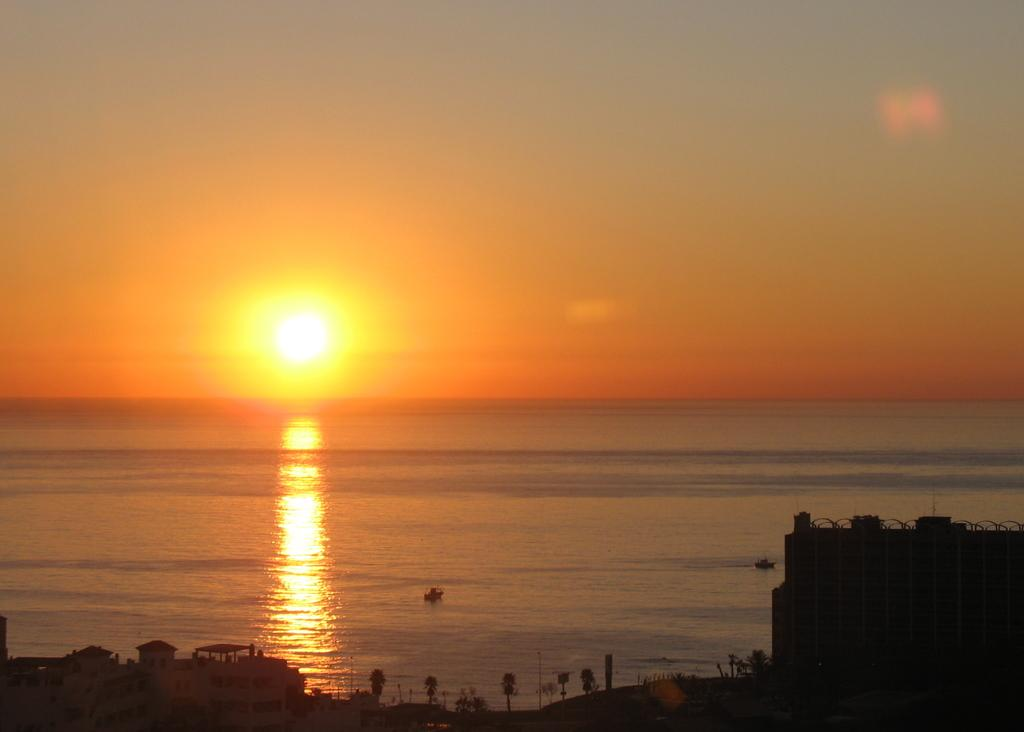What type of structures can be seen in the image? There are buildings in the image. What other natural elements are present in the image? There are trees in the image. Can you identify any objects on the water? Yes, there are two objects on the water that resemble boats. What is visible in the background of the image? The sky is visible in the background of the image. What celestial body can be seen in the sky? The sun is observable in the sky. Where is the playground located in the image? There is no playground present in the image. What type of brush is being used by the army in the image? There is no brush or army present in the image. 